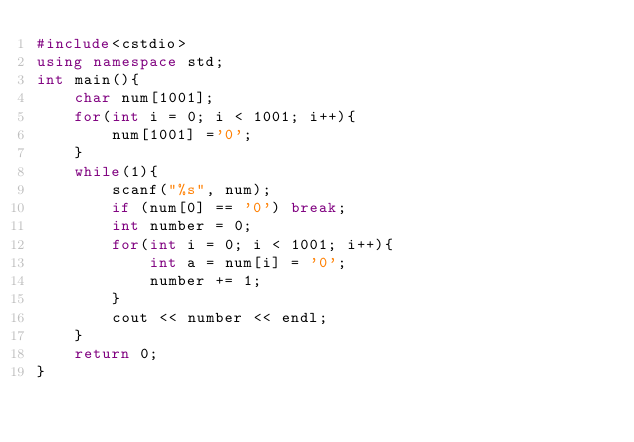Convert code to text. <code><loc_0><loc_0><loc_500><loc_500><_C++_>#include<cstdio>
using namespace std;
int main(){
    char num[1001];
    for(int i = 0; i < 1001; i++){
        num[1001] ='0';
    }
    while(1){
        scanf("%s", num);
        if (num[0] == '0') break;
        int number = 0;
        for(int i = 0; i < 1001; i++){
            int a = num[i] = '0';
            number += 1;
        }
        cout << number << endl;
    }
    return 0;
}
</code> 